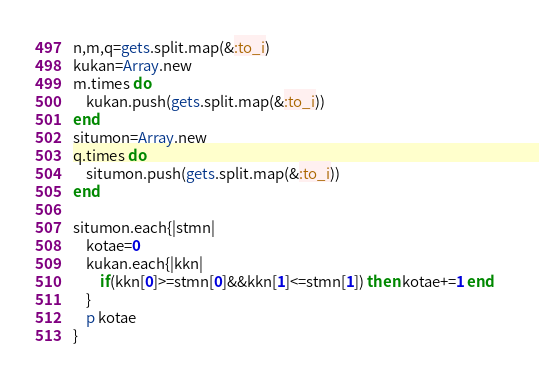<code> <loc_0><loc_0><loc_500><loc_500><_Ruby_>n,m,q=gets.split.map(&:to_i)
kukan=Array.new
m.times do 
    kukan.push(gets.split.map(&:to_i))
end
situmon=Array.new
q.times do
    situmon.push(gets.split.map(&:to_i))
end

situmon.each{|stmn|
    kotae=0
    kukan.each{|kkn|
        if(kkn[0]>=stmn[0]&&kkn[1]<=stmn[1]) then kotae+=1 end   
    }
    p kotae
}</code> 